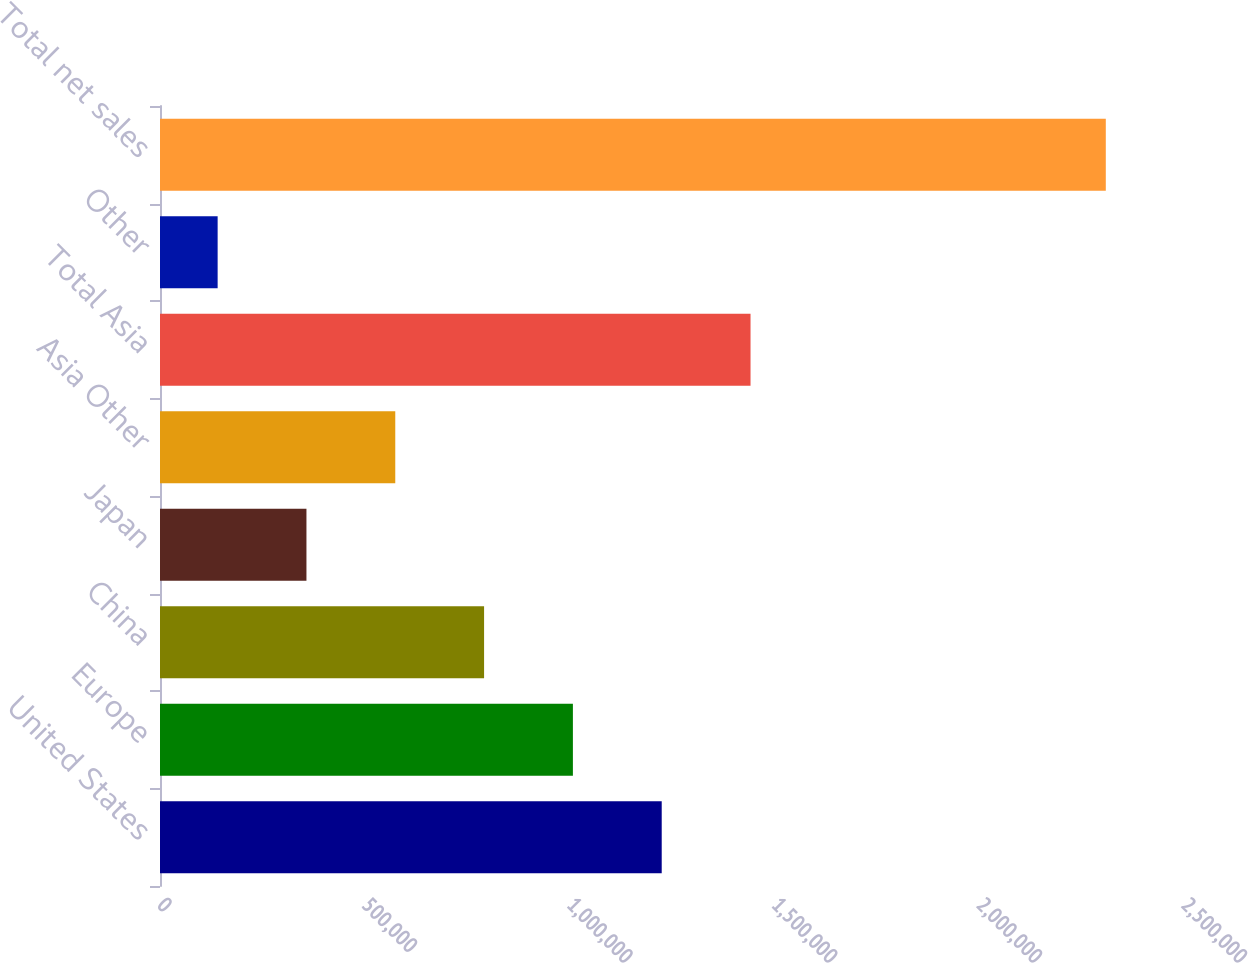Convert chart to OTSL. <chart><loc_0><loc_0><loc_500><loc_500><bar_chart><fcel>United States<fcel>Europe<fcel>China<fcel>Japan<fcel>Asia Other<fcel>Total Asia<fcel>Other<fcel>Total net sales<nl><fcel>1.2249e+06<fcel>1.00806e+06<fcel>791224<fcel>357551<fcel>574388<fcel>1.44173e+06<fcel>140715<fcel>2.30908e+06<nl></chart> 